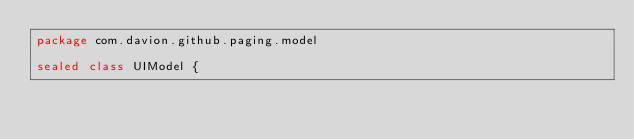Convert code to text. <code><loc_0><loc_0><loc_500><loc_500><_Kotlin_>package com.davion.github.paging.model

sealed class UIModel {</code> 